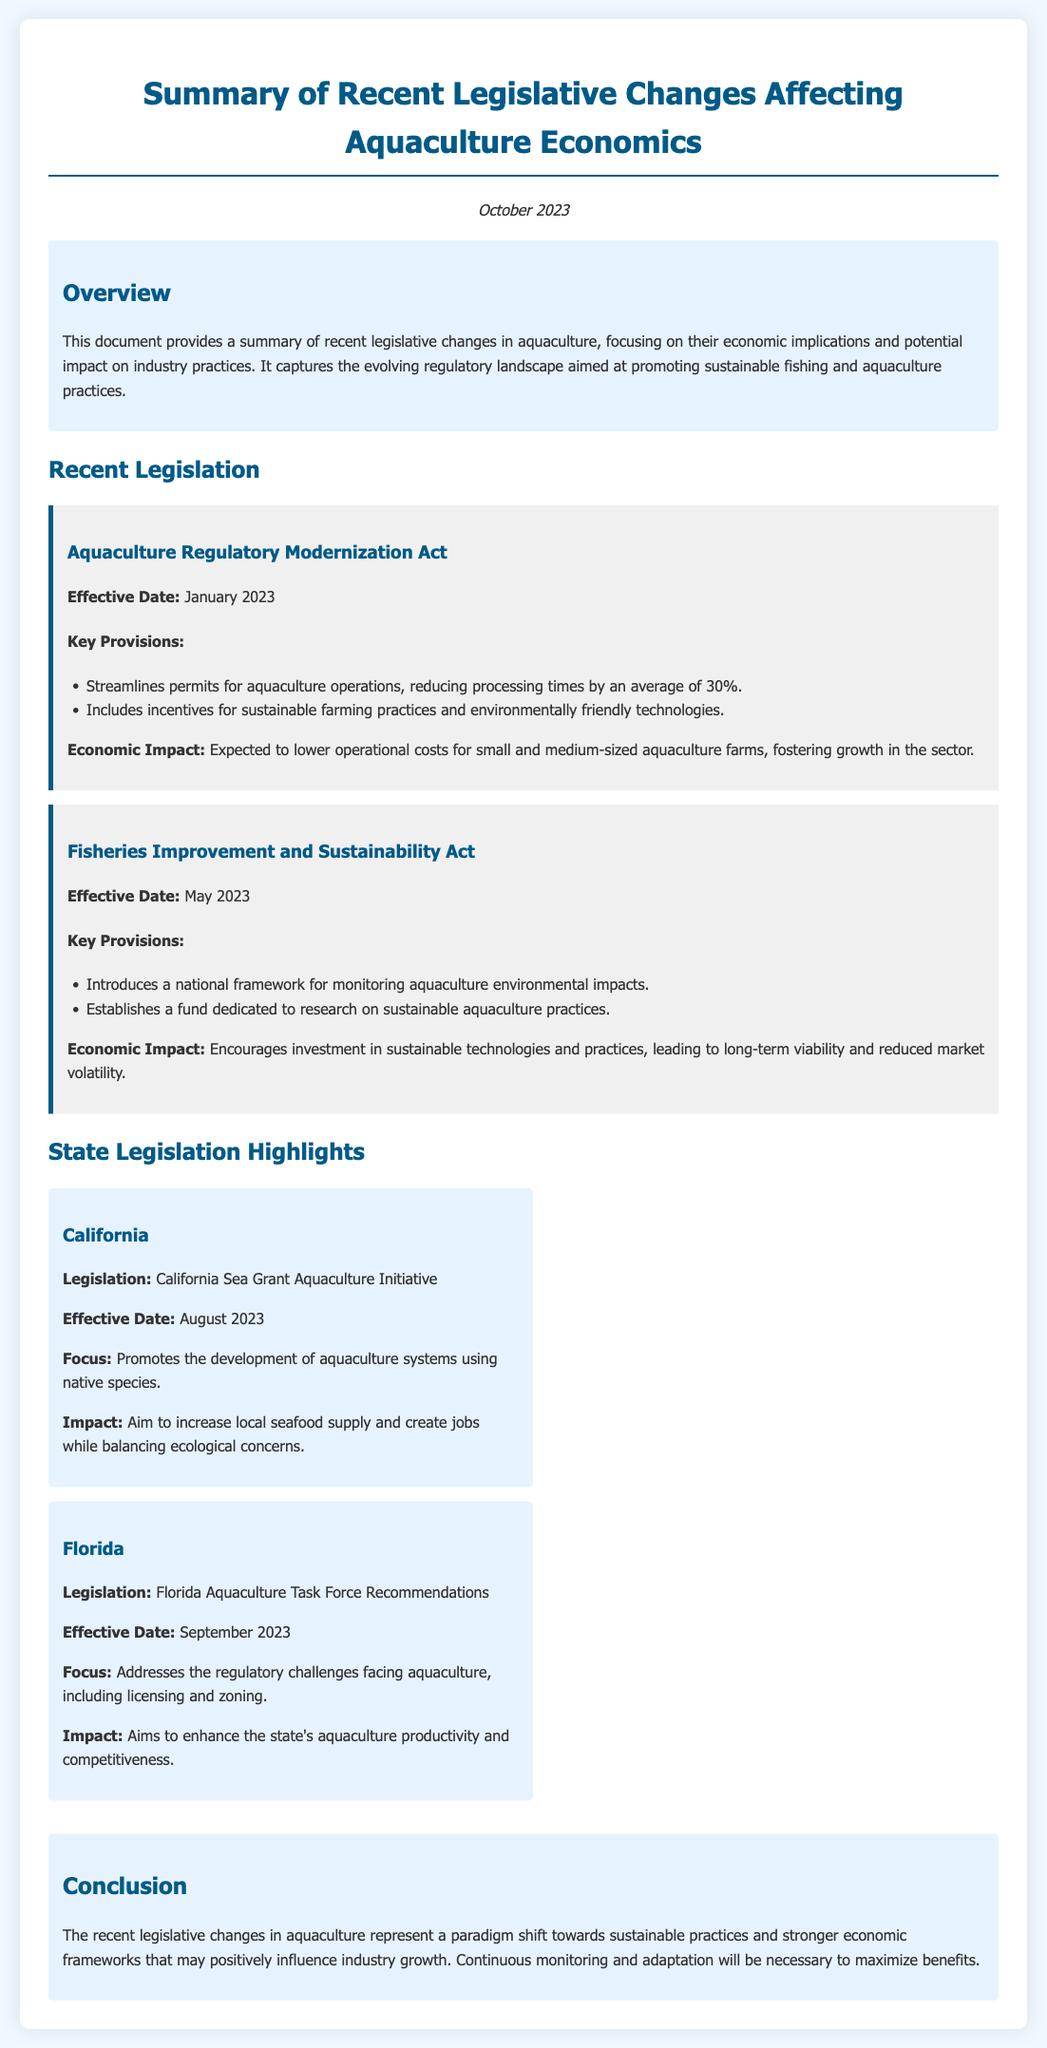What is the effective date of the Aquaculture Regulatory Modernization Act? The effective date is mentioned as January 2023.
Answer: January 2023 What is one of the key provisions of the Fisheries Improvement and Sustainability Act? One key provision is the introduction of a national framework for monitoring aquaculture environmental impacts.
Answer: National framework for monitoring environmental impacts What is the focus of California's legislation regarding aquaculture? The focus is on promoting the development of aquaculture systems using native species.
Answer: Development of aquaculture systems using native species What economic impact is expected from the Aquaculture Regulatory Modernization Act? The expected impact is a lowering of operational costs for small and medium-sized aquaculture farms.
Answer: Lower operational costs Which act establishes a fund dedicated to research on sustainable aquaculture practices? This is established by the Fisheries Improvement and Sustainability Act.
Answer: Fisheries Improvement and Sustainability Act What was a primary aim of the Florida Aquaculture Task Force Recommendations? The primary aim is to enhance the state's aquaculture productivity and competitiveness.
Answer: Enhance aquaculture productivity and competitiveness What summarizes the conclusion of the document? The conclusion states that recent legislative changes represent a paradigm shift towards sustainable practices.
Answer: Paradigm shift towards sustainable practices How many percent will processing times be reduced for aquaculture operations according to the Aquaculture Regulatory Modernization Act? Processing times will be reduced by an average of 30%.
Answer: 30% What is the title of the document? The title is "Summary of Recent Legislative Changes Affecting Aquaculture Economics."
Answer: Summary of Recent Legislative Changes Affecting Aquaculture Economics 